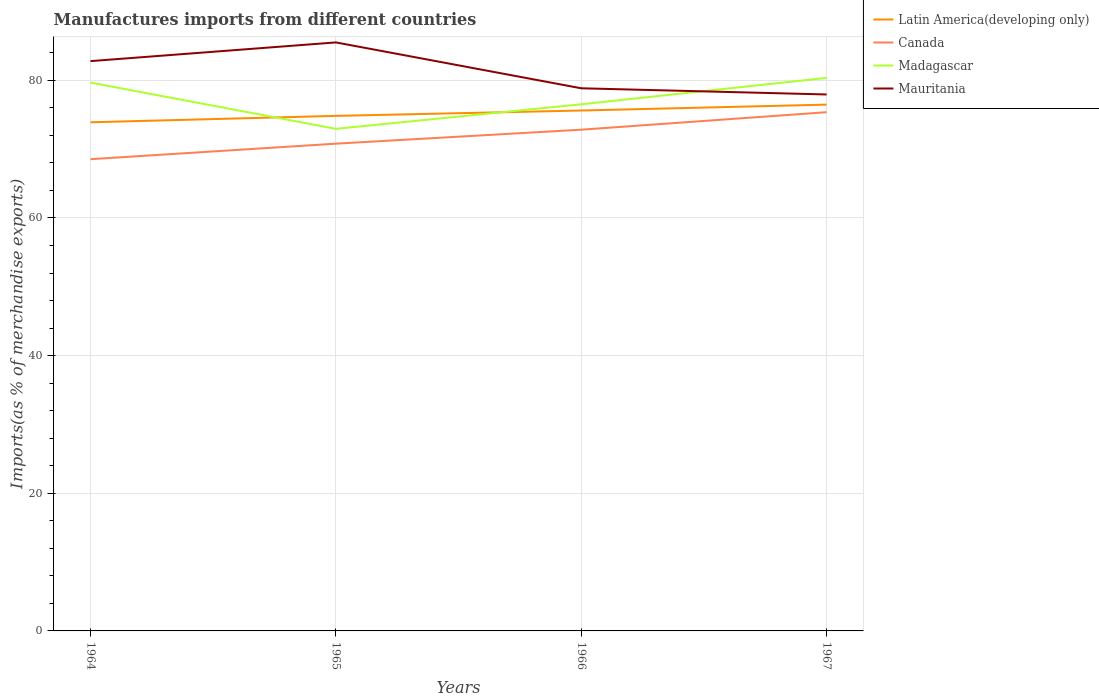How many different coloured lines are there?
Your answer should be very brief. 4. Across all years, what is the maximum percentage of imports to different countries in Madagascar?
Give a very brief answer. 72.95. In which year was the percentage of imports to different countries in Madagascar maximum?
Keep it short and to the point. 1965. What is the total percentage of imports to different countries in Canada in the graph?
Provide a short and direct response. -4.57. What is the difference between the highest and the second highest percentage of imports to different countries in Mauritania?
Ensure brevity in your answer.  7.56. How many lines are there?
Make the answer very short. 4. Are the values on the major ticks of Y-axis written in scientific E-notation?
Provide a succinct answer. No. Does the graph contain grids?
Your response must be concise. Yes. How are the legend labels stacked?
Give a very brief answer. Vertical. What is the title of the graph?
Provide a short and direct response. Manufactures imports from different countries. Does "Sweden" appear as one of the legend labels in the graph?
Offer a very short reply. No. What is the label or title of the X-axis?
Ensure brevity in your answer.  Years. What is the label or title of the Y-axis?
Your answer should be compact. Imports(as % of merchandise exports). What is the Imports(as % of merchandise exports) of Latin America(developing only) in 1964?
Keep it short and to the point. 73.9. What is the Imports(as % of merchandise exports) of Canada in 1964?
Offer a terse response. 68.54. What is the Imports(as % of merchandise exports) of Madagascar in 1964?
Your answer should be very brief. 79.67. What is the Imports(as % of merchandise exports) in Mauritania in 1964?
Make the answer very short. 82.79. What is the Imports(as % of merchandise exports) of Latin America(developing only) in 1965?
Keep it short and to the point. 74.83. What is the Imports(as % of merchandise exports) in Canada in 1965?
Offer a terse response. 70.79. What is the Imports(as % of merchandise exports) in Madagascar in 1965?
Keep it short and to the point. 72.95. What is the Imports(as % of merchandise exports) of Mauritania in 1965?
Provide a short and direct response. 85.5. What is the Imports(as % of merchandise exports) in Latin America(developing only) in 1966?
Your response must be concise. 75.61. What is the Imports(as % of merchandise exports) in Canada in 1966?
Provide a succinct answer. 72.83. What is the Imports(as % of merchandise exports) of Madagascar in 1966?
Give a very brief answer. 76.51. What is the Imports(as % of merchandise exports) of Mauritania in 1966?
Give a very brief answer. 78.84. What is the Imports(as % of merchandise exports) of Latin America(developing only) in 1967?
Your answer should be very brief. 76.46. What is the Imports(as % of merchandise exports) of Canada in 1967?
Give a very brief answer. 75.37. What is the Imports(as % of merchandise exports) in Madagascar in 1967?
Keep it short and to the point. 80.35. What is the Imports(as % of merchandise exports) in Mauritania in 1967?
Provide a short and direct response. 77.94. Across all years, what is the maximum Imports(as % of merchandise exports) of Latin America(developing only)?
Offer a terse response. 76.46. Across all years, what is the maximum Imports(as % of merchandise exports) in Canada?
Make the answer very short. 75.37. Across all years, what is the maximum Imports(as % of merchandise exports) of Madagascar?
Keep it short and to the point. 80.35. Across all years, what is the maximum Imports(as % of merchandise exports) of Mauritania?
Your response must be concise. 85.5. Across all years, what is the minimum Imports(as % of merchandise exports) in Latin America(developing only)?
Your response must be concise. 73.9. Across all years, what is the minimum Imports(as % of merchandise exports) in Canada?
Provide a short and direct response. 68.54. Across all years, what is the minimum Imports(as % of merchandise exports) in Madagascar?
Your response must be concise. 72.95. Across all years, what is the minimum Imports(as % of merchandise exports) in Mauritania?
Provide a succinct answer. 77.94. What is the total Imports(as % of merchandise exports) in Latin America(developing only) in the graph?
Your answer should be compact. 300.81. What is the total Imports(as % of merchandise exports) in Canada in the graph?
Ensure brevity in your answer.  287.52. What is the total Imports(as % of merchandise exports) of Madagascar in the graph?
Offer a terse response. 309.48. What is the total Imports(as % of merchandise exports) in Mauritania in the graph?
Your response must be concise. 325.07. What is the difference between the Imports(as % of merchandise exports) of Latin America(developing only) in 1964 and that in 1965?
Offer a terse response. -0.93. What is the difference between the Imports(as % of merchandise exports) in Canada in 1964 and that in 1965?
Your answer should be compact. -2.26. What is the difference between the Imports(as % of merchandise exports) in Madagascar in 1964 and that in 1965?
Offer a very short reply. 6.72. What is the difference between the Imports(as % of merchandise exports) in Mauritania in 1964 and that in 1965?
Your response must be concise. -2.72. What is the difference between the Imports(as % of merchandise exports) of Latin America(developing only) in 1964 and that in 1966?
Your answer should be very brief. -1.71. What is the difference between the Imports(as % of merchandise exports) in Canada in 1964 and that in 1966?
Your answer should be very brief. -4.29. What is the difference between the Imports(as % of merchandise exports) of Madagascar in 1964 and that in 1966?
Offer a terse response. 3.15. What is the difference between the Imports(as % of merchandise exports) in Mauritania in 1964 and that in 1966?
Keep it short and to the point. 3.95. What is the difference between the Imports(as % of merchandise exports) of Latin America(developing only) in 1964 and that in 1967?
Provide a short and direct response. -2.56. What is the difference between the Imports(as % of merchandise exports) in Canada in 1964 and that in 1967?
Provide a short and direct response. -6.83. What is the difference between the Imports(as % of merchandise exports) of Madagascar in 1964 and that in 1967?
Provide a short and direct response. -0.68. What is the difference between the Imports(as % of merchandise exports) of Mauritania in 1964 and that in 1967?
Provide a short and direct response. 4.85. What is the difference between the Imports(as % of merchandise exports) of Latin America(developing only) in 1965 and that in 1966?
Provide a succinct answer. -0.78. What is the difference between the Imports(as % of merchandise exports) of Canada in 1965 and that in 1966?
Make the answer very short. -2.03. What is the difference between the Imports(as % of merchandise exports) of Madagascar in 1965 and that in 1966?
Ensure brevity in your answer.  -3.57. What is the difference between the Imports(as % of merchandise exports) of Mauritania in 1965 and that in 1966?
Provide a succinct answer. 6.66. What is the difference between the Imports(as % of merchandise exports) in Latin America(developing only) in 1965 and that in 1967?
Offer a very short reply. -1.63. What is the difference between the Imports(as % of merchandise exports) in Canada in 1965 and that in 1967?
Your answer should be compact. -4.57. What is the difference between the Imports(as % of merchandise exports) of Madagascar in 1965 and that in 1967?
Ensure brevity in your answer.  -7.4. What is the difference between the Imports(as % of merchandise exports) of Mauritania in 1965 and that in 1967?
Your response must be concise. 7.56. What is the difference between the Imports(as % of merchandise exports) of Latin America(developing only) in 1966 and that in 1967?
Give a very brief answer. -0.85. What is the difference between the Imports(as % of merchandise exports) in Canada in 1966 and that in 1967?
Offer a very short reply. -2.54. What is the difference between the Imports(as % of merchandise exports) in Madagascar in 1966 and that in 1967?
Give a very brief answer. -3.84. What is the difference between the Imports(as % of merchandise exports) of Mauritania in 1966 and that in 1967?
Your answer should be very brief. 0.9. What is the difference between the Imports(as % of merchandise exports) of Latin America(developing only) in 1964 and the Imports(as % of merchandise exports) of Canada in 1965?
Provide a succinct answer. 3.11. What is the difference between the Imports(as % of merchandise exports) in Latin America(developing only) in 1964 and the Imports(as % of merchandise exports) in Madagascar in 1965?
Your answer should be compact. 0.95. What is the difference between the Imports(as % of merchandise exports) in Latin America(developing only) in 1964 and the Imports(as % of merchandise exports) in Mauritania in 1965?
Offer a very short reply. -11.6. What is the difference between the Imports(as % of merchandise exports) in Canada in 1964 and the Imports(as % of merchandise exports) in Madagascar in 1965?
Give a very brief answer. -4.41. What is the difference between the Imports(as % of merchandise exports) of Canada in 1964 and the Imports(as % of merchandise exports) of Mauritania in 1965?
Provide a short and direct response. -16.97. What is the difference between the Imports(as % of merchandise exports) of Madagascar in 1964 and the Imports(as % of merchandise exports) of Mauritania in 1965?
Keep it short and to the point. -5.84. What is the difference between the Imports(as % of merchandise exports) of Latin America(developing only) in 1964 and the Imports(as % of merchandise exports) of Canada in 1966?
Offer a very short reply. 1.08. What is the difference between the Imports(as % of merchandise exports) of Latin America(developing only) in 1964 and the Imports(as % of merchandise exports) of Madagascar in 1966?
Your response must be concise. -2.61. What is the difference between the Imports(as % of merchandise exports) in Latin America(developing only) in 1964 and the Imports(as % of merchandise exports) in Mauritania in 1966?
Give a very brief answer. -4.94. What is the difference between the Imports(as % of merchandise exports) in Canada in 1964 and the Imports(as % of merchandise exports) in Madagascar in 1966?
Offer a very short reply. -7.98. What is the difference between the Imports(as % of merchandise exports) in Canada in 1964 and the Imports(as % of merchandise exports) in Mauritania in 1966?
Offer a very short reply. -10.3. What is the difference between the Imports(as % of merchandise exports) of Madagascar in 1964 and the Imports(as % of merchandise exports) of Mauritania in 1966?
Your answer should be compact. 0.83. What is the difference between the Imports(as % of merchandise exports) in Latin America(developing only) in 1964 and the Imports(as % of merchandise exports) in Canada in 1967?
Give a very brief answer. -1.47. What is the difference between the Imports(as % of merchandise exports) of Latin America(developing only) in 1964 and the Imports(as % of merchandise exports) of Madagascar in 1967?
Provide a short and direct response. -6.45. What is the difference between the Imports(as % of merchandise exports) of Latin America(developing only) in 1964 and the Imports(as % of merchandise exports) of Mauritania in 1967?
Provide a succinct answer. -4.04. What is the difference between the Imports(as % of merchandise exports) in Canada in 1964 and the Imports(as % of merchandise exports) in Madagascar in 1967?
Give a very brief answer. -11.81. What is the difference between the Imports(as % of merchandise exports) of Canada in 1964 and the Imports(as % of merchandise exports) of Mauritania in 1967?
Keep it short and to the point. -9.4. What is the difference between the Imports(as % of merchandise exports) in Madagascar in 1964 and the Imports(as % of merchandise exports) in Mauritania in 1967?
Your answer should be compact. 1.73. What is the difference between the Imports(as % of merchandise exports) of Latin America(developing only) in 1965 and the Imports(as % of merchandise exports) of Canada in 1966?
Offer a terse response. 2.01. What is the difference between the Imports(as % of merchandise exports) of Latin America(developing only) in 1965 and the Imports(as % of merchandise exports) of Madagascar in 1966?
Your response must be concise. -1.68. What is the difference between the Imports(as % of merchandise exports) in Latin America(developing only) in 1965 and the Imports(as % of merchandise exports) in Mauritania in 1966?
Your answer should be very brief. -4.01. What is the difference between the Imports(as % of merchandise exports) of Canada in 1965 and the Imports(as % of merchandise exports) of Madagascar in 1966?
Offer a terse response. -5.72. What is the difference between the Imports(as % of merchandise exports) of Canada in 1965 and the Imports(as % of merchandise exports) of Mauritania in 1966?
Provide a succinct answer. -8.05. What is the difference between the Imports(as % of merchandise exports) in Madagascar in 1965 and the Imports(as % of merchandise exports) in Mauritania in 1966?
Your response must be concise. -5.89. What is the difference between the Imports(as % of merchandise exports) of Latin America(developing only) in 1965 and the Imports(as % of merchandise exports) of Canada in 1967?
Your answer should be compact. -0.53. What is the difference between the Imports(as % of merchandise exports) of Latin America(developing only) in 1965 and the Imports(as % of merchandise exports) of Madagascar in 1967?
Ensure brevity in your answer.  -5.52. What is the difference between the Imports(as % of merchandise exports) of Latin America(developing only) in 1965 and the Imports(as % of merchandise exports) of Mauritania in 1967?
Make the answer very short. -3.11. What is the difference between the Imports(as % of merchandise exports) in Canada in 1965 and the Imports(as % of merchandise exports) in Madagascar in 1967?
Provide a succinct answer. -9.56. What is the difference between the Imports(as % of merchandise exports) in Canada in 1965 and the Imports(as % of merchandise exports) in Mauritania in 1967?
Your answer should be compact. -7.15. What is the difference between the Imports(as % of merchandise exports) of Madagascar in 1965 and the Imports(as % of merchandise exports) of Mauritania in 1967?
Keep it short and to the point. -4.99. What is the difference between the Imports(as % of merchandise exports) in Latin America(developing only) in 1966 and the Imports(as % of merchandise exports) in Canada in 1967?
Offer a very short reply. 0.24. What is the difference between the Imports(as % of merchandise exports) of Latin America(developing only) in 1966 and the Imports(as % of merchandise exports) of Madagascar in 1967?
Provide a short and direct response. -4.74. What is the difference between the Imports(as % of merchandise exports) in Latin America(developing only) in 1966 and the Imports(as % of merchandise exports) in Mauritania in 1967?
Offer a very short reply. -2.33. What is the difference between the Imports(as % of merchandise exports) of Canada in 1966 and the Imports(as % of merchandise exports) of Madagascar in 1967?
Your answer should be compact. -7.53. What is the difference between the Imports(as % of merchandise exports) of Canada in 1966 and the Imports(as % of merchandise exports) of Mauritania in 1967?
Offer a very short reply. -5.12. What is the difference between the Imports(as % of merchandise exports) in Madagascar in 1966 and the Imports(as % of merchandise exports) in Mauritania in 1967?
Offer a terse response. -1.43. What is the average Imports(as % of merchandise exports) in Latin America(developing only) per year?
Ensure brevity in your answer.  75.2. What is the average Imports(as % of merchandise exports) of Canada per year?
Keep it short and to the point. 71.88. What is the average Imports(as % of merchandise exports) of Madagascar per year?
Make the answer very short. 77.37. What is the average Imports(as % of merchandise exports) of Mauritania per year?
Make the answer very short. 81.27. In the year 1964, what is the difference between the Imports(as % of merchandise exports) of Latin America(developing only) and Imports(as % of merchandise exports) of Canada?
Provide a succinct answer. 5.36. In the year 1964, what is the difference between the Imports(as % of merchandise exports) in Latin America(developing only) and Imports(as % of merchandise exports) in Madagascar?
Your answer should be very brief. -5.77. In the year 1964, what is the difference between the Imports(as % of merchandise exports) of Latin America(developing only) and Imports(as % of merchandise exports) of Mauritania?
Make the answer very short. -8.89. In the year 1964, what is the difference between the Imports(as % of merchandise exports) in Canada and Imports(as % of merchandise exports) in Madagascar?
Your answer should be compact. -11.13. In the year 1964, what is the difference between the Imports(as % of merchandise exports) in Canada and Imports(as % of merchandise exports) in Mauritania?
Give a very brief answer. -14.25. In the year 1964, what is the difference between the Imports(as % of merchandise exports) in Madagascar and Imports(as % of merchandise exports) in Mauritania?
Your response must be concise. -3.12. In the year 1965, what is the difference between the Imports(as % of merchandise exports) of Latin America(developing only) and Imports(as % of merchandise exports) of Canada?
Give a very brief answer. 4.04. In the year 1965, what is the difference between the Imports(as % of merchandise exports) in Latin America(developing only) and Imports(as % of merchandise exports) in Madagascar?
Offer a terse response. 1.88. In the year 1965, what is the difference between the Imports(as % of merchandise exports) of Latin America(developing only) and Imports(as % of merchandise exports) of Mauritania?
Your answer should be compact. -10.67. In the year 1965, what is the difference between the Imports(as % of merchandise exports) of Canada and Imports(as % of merchandise exports) of Madagascar?
Ensure brevity in your answer.  -2.16. In the year 1965, what is the difference between the Imports(as % of merchandise exports) in Canada and Imports(as % of merchandise exports) in Mauritania?
Your answer should be compact. -14.71. In the year 1965, what is the difference between the Imports(as % of merchandise exports) of Madagascar and Imports(as % of merchandise exports) of Mauritania?
Make the answer very short. -12.56. In the year 1966, what is the difference between the Imports(as % of merchandise exports) of Latin America(developing only) and Imports(as % of merchandise exports) of Canada?
Your answer should be very brief. 2.79. In the year 1966, what is the difference between the Imports(as % of merchandise exports) of Latin America(developing only) and Imports(as % of merchandise exports) of Madagascar?
Ensure brevity in your answer.  -0.9. In the year 1966, what is the difference between the Imports(as % of merchandise exports) in Latin America(developing only) and Imports(as % of merchandise exports) in Mauritania?
Keep it short and to the point. -3.23. In the year 1966, what is the difference between the Imports(as % of merchandise exports) in Canada and Imports(as % of merchandise exports) in Madagascar?
Your answer should be very brief. -3.69. In the year 1966, what is the difference between the Imports(as % of merchandise exports) of Canada and Imports(as % of merchandise exports) of Mauritania?
Your response must be concise. -6.01. In the year 1966, what is the difference between the Imports(as % of merchandise exports) in Madagascar and Imports(as % of merchandise exports) in Mauritania?
Your answer should be compact. -2.32. In the year 1967, what is the difference between the Imports(as % of merchandise exports) of Latin America(developing only) and Imports(as % of merchandise exports) of Canada?
Keep it short and to the point. 1.1. In the year 1967, what is the difference between the Imports(as % of merchandise exports) in Latin America(developing only) and Imports(as % of merchandise exports) in Madagascar?
Make the answer very short. -3.89. In the year 1967, what is the difference between the Imports(as % of merchandise exports) in Latin America(developing only) and Imports(as % of merchandise exports) in Mauritania?
Provide a short and direct response. -1.48. In the year 1967, what is the difference between the Imports(as % of merchandise exports) in Canada and Imports(as % of merchandise exports) in Madagascar?
Offer a very short reply. -4.99. In the year 1967, what is the difference between the Imports(as % of merchandise exports) of Canada and Imports(as % of merchandise exports) of Mauritania?
Ensure brevity in your answer.  -2.58. In the year 1967, what is the difference between the Imports(as % of merchandise exports) of Madagascar and Imports(as % of merchandise exports) of Mauritania?
Provide a short and direct response. 2.41. What is the ratio of the Imports(as % of merchandise exports) in Latin America(developing only) in 1964 to that in 1965?
Provide a short and direct response. 0.99. What is the ratio of the Imports(as % of merchandise exports) in Canada in 1964 to that in 1965?
Offer a terse response. 0.97. What is the ratio of the Imports(as % of merchandise exports) of Madagascar in 1964 to that in 1965?
Offer a very short reply. 1.09. What is the ratio of the Imports(as % of merchandise exports) of Mauritania in 1964 to that in 1965?
Keep it short and to the point. 0.97. What is the ratio of the Imports(as % of merchandise exports) in Latin America(developing only) in 1964 to that in 1966?
Offer a very short reply. 0.98. What is the ratio of the Imports(as % of merchandise exports) of Canada in 1964 to that in 1966?
Offer a terse response. 0.94. What is the ratio of the Imports(as % of merchandise exports) of Madagascar in 1964 to that in 1966?
Provide a short and direct response. 1.04. What is the ratio of the Imports(as % of merchandise exports) of Mauritania in 1964 to that in 1966?
Provide a succinct answer. 1.05. What is the ratio of the Imports(as % of merchandise exports) in Latin America(developing only) in 1964 to that in 1967?
Your answer should be very brief. 0.97. What is the ratio of the Imports(as % of merchandise exports) of Canada in 1964 to that in 1967?
Your response must be concise. 0.91. What is the ratio of the Imports(as % of merchandise exports) in Mauritania in 1964 to that in 1967?
Make the answer very short. 1.06. What is the ratio of the Imports(as % of merchandise exports) in Latin America(developing only) in 1965 to that in 1966?
Provide a short and direct response. 0.99. What is the ratio of the Imports(as % of merchandise exports) in Canada in 1965 to that in 1966?
Provide a short and direct response. 0.97. What is the ratio of the Imports(as % of merchandise exports) in Madagascar in 1965 to that in 1966?
Offer a very short reply. 0.95. What is the ratio of the Imports(as % of merchandise exports) in Mauritania in 1965 to that in 1966?
Offer a very short reply. 1.08. What is the ratio of the Imports(as % of merchandise exports) in Latin America(developing only) in 1965 to that in 1967?
Ensure brevity in your answer.  0.98. What is the ratio of the Imports(as % of merchandise exports) of Canada in 1965 to that in 1967?
Your answer should be very brief. 0.94. What is the ratio of the Imports(as % of merchandise exports) of Madagascar in 1965 to that in 1967?
Ensure brevity in your answer.  0.91. What is the ratio of the Imports(as % of merchandise exports) in Mauritania in 1965 to that in 1967?
Your response must be concise. 1.1. What is the ratio of the Imports(as % of merchandise exports) of Canada in 1966 to that in 1967?
Provide a succinct answer. 0.97. What is the ratio of the Imports(as % of merchandise exports) in Madagascar in 1966 to that in 1967?
Ensure brevity in your answer.  0.95. What is the ratio of the Imports(as % of merchandise exports) of Mauritania in 1966 to that in 1967?
Your response must be concise. 1.01. What is the difference between the highest and the second highest Imports(as % of merchandise exports) in Latin America(developing only)?
Ensure brevity in your answer.  0.85. What is the difference between the highest and the second highest Imports(as % of merchandise exports) of Canada?
Your response must be concise. 2.54. What is the difference between the highest and the second highest Imports(as % of merchandise exports) in Madagascar?
Provide a short and direct response. 0.68. What is the difference between the highest and the second highest Imports(as % of merchandise exports) in Mauritania?
Offer a terse response. 2.72. What is the difference between the highest and the lowest Imports(as % of merchandise exports) of Latin America(developing only)?
Ensure brevity in your answer.  2.56. What is the difference between the highest and the lowest Imports(as % of merchandise exports) of Canada?
Ensure brevity in your answer.  6.83. What is the difference between the highest and the lowest Imports(as % of merchandise exports) in Madagascar?
Provide a short and direct response. 7.4. What is the difference between the highest and the lowest Imports(as % of merchandise exports) in Mauritania?
Make the answer very short. 7.56. 